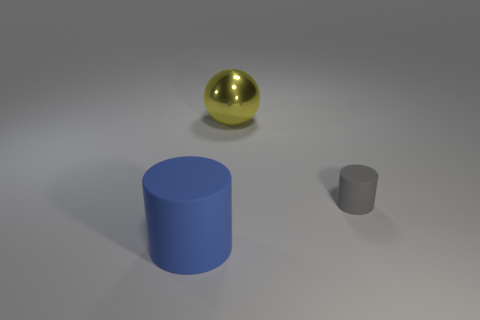Are there any other things that are the same size as the gray object?
Make the answer very short. No. Are there any other things that have the same shape as the big metal thing?
Provide a succinct answer. No. How many objects are large things that are in front of the yellow metallic object or blue matte things to the left of the yellow sphere?
Provide a succinct answer. 1. The other blue object that is the same material as the tiny object is what shape?
Your answer should be very brief. Cylinder. Is there any other thing that is the same color as the tiny thing?
Provide a succinct answer. No. There is a tiny gray thing that is the same shape as the blue object; what is its material?
Ensure brevity in your answer.  Rubber. What number of other objects are the same size as the metal ball?
Keep it short and to the point. 1. What is the material of the big blue thing?
Offer a terse response. Rubber. Is the number of gray rubber objects behind the blue cylinder greater than the number of big yellow things?
Give a very brief answer. No. Is there a small green matte ball?
Offer a very short reply. No. 